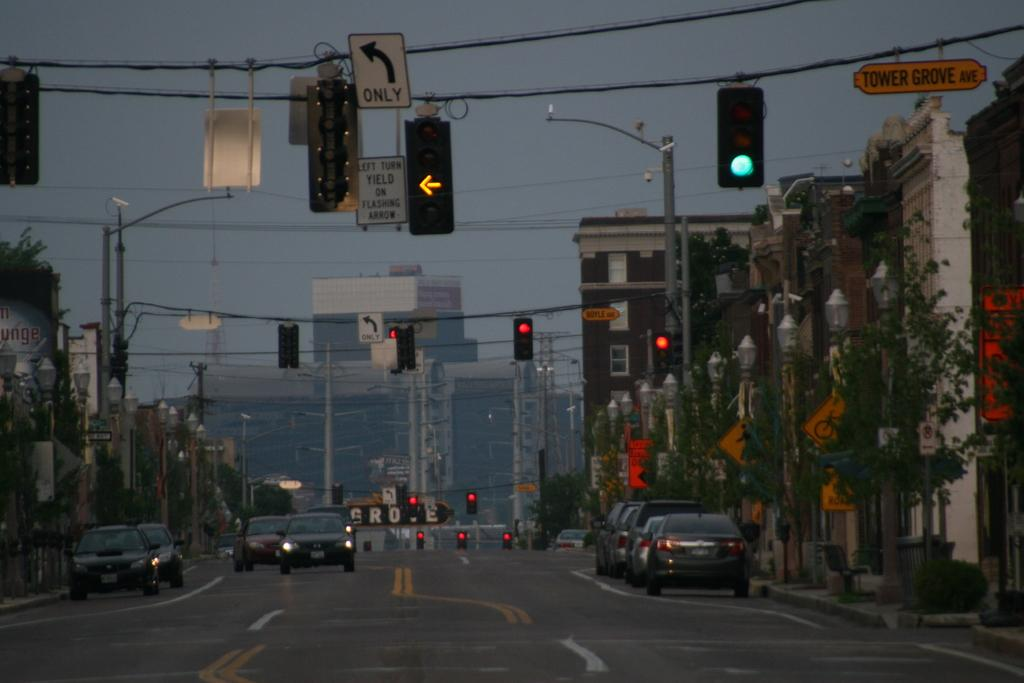<image>
Create a compact narrative representing the image presented. A busy city street with a green light at the intersection of Tower Grove Avenue. 